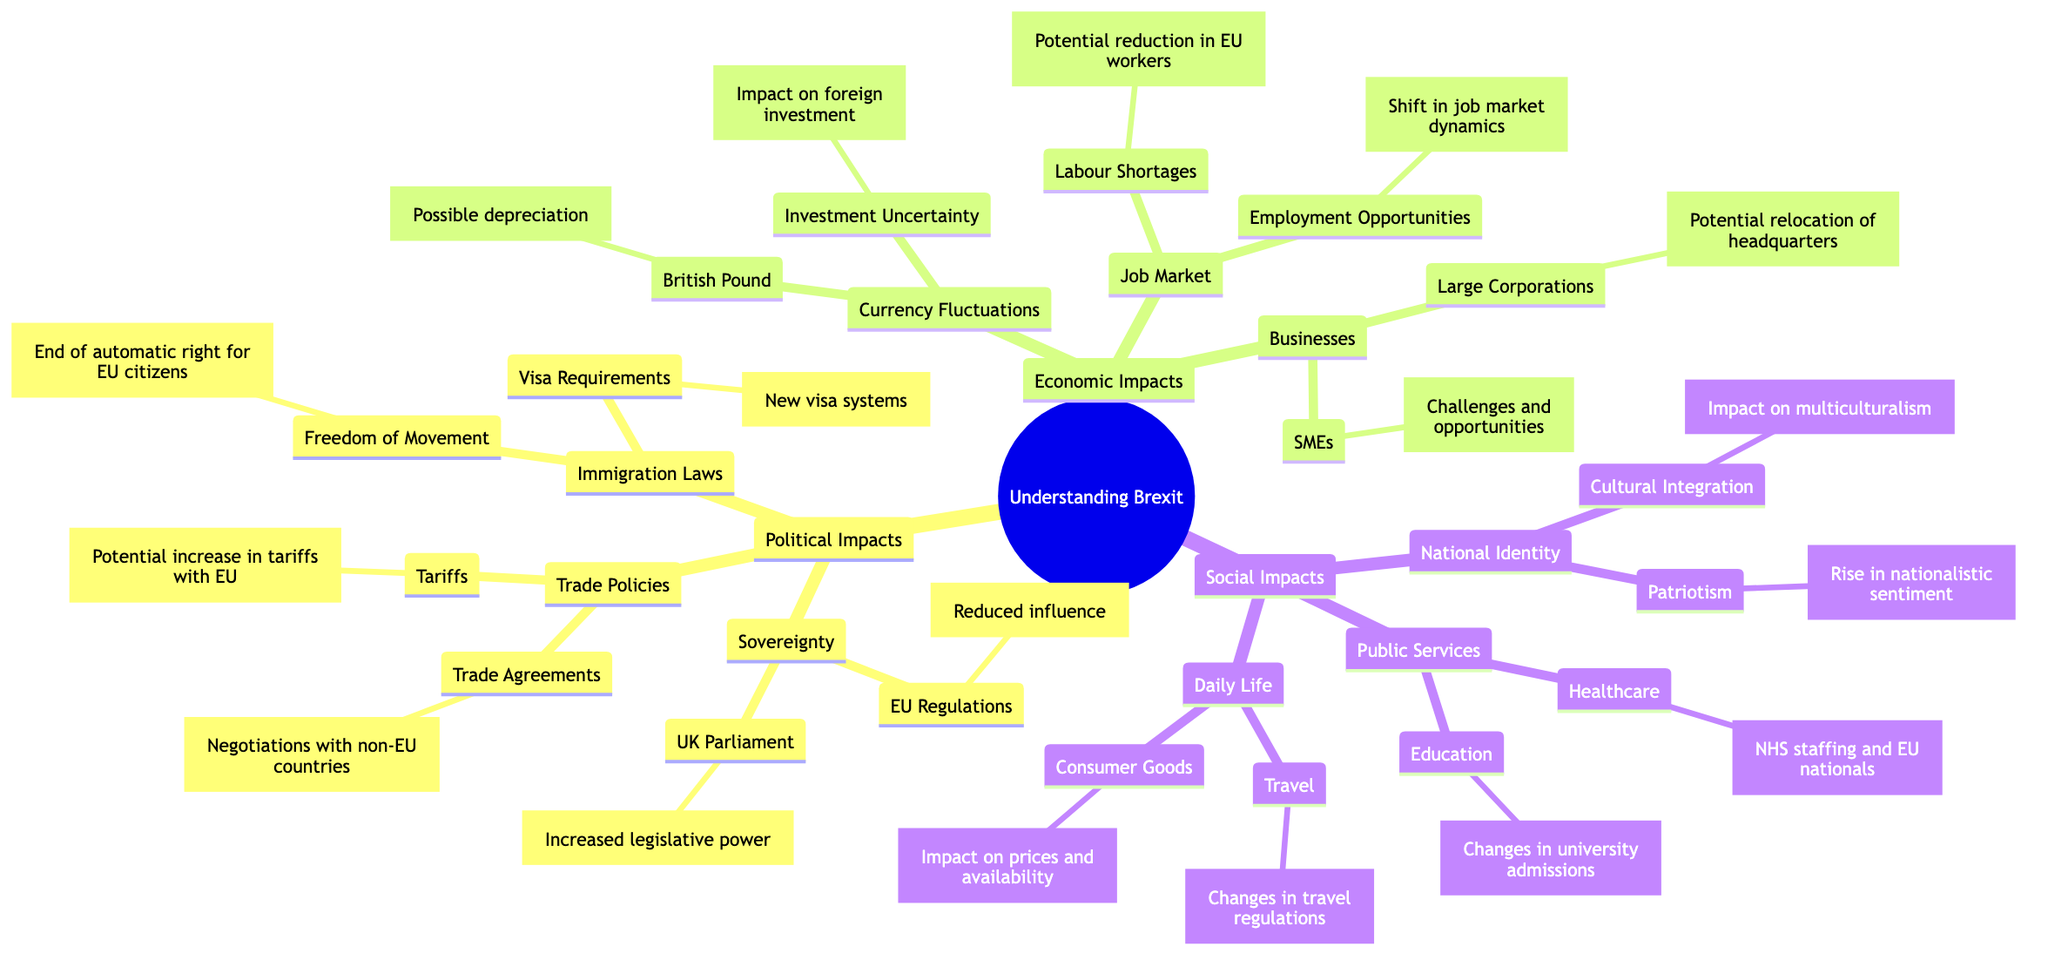What are the two main aspects of Political Impacts in the diagram? The diagram shows Political Impacts divided into three sections: Sovereignty, Trade Policies, and Immigration Laws. The question specifies to cite two aspects, so we can select any two from these three sections.
Answer: Sovereignty, Trade Policies How many aspects of Economic Impacts are detailed in the diagram? The Economic Impacts section has three sub-sections: Currency Fluctuations, Job Market, and Businesses, thus totaling three aspects.
Answer: 3 What does 'Freedom of Movement' refer to in the Immigration Laws section? In the diagram, 'Freedom of Movement' signifies the end of the automatic right for EU citizens to live and work in the UK. Therefore, it answers what this term conveys.
Answer: End of automatic right for EU citizens What might happen to the British Pound according to the Currency Fluctuations section? The Currency Fluctuations section specifies that the British Pound may face possible depreciation, indicating a potential decrease in its value.
Answer: Possible depreciation How does the rise in nationalistic sentiment affect Cultural Integration as seen in the diagram? The diagram links National Identity with Patriotism, which indicates a rise in nationalistic sentiment, and connects this concept to Cultural Integration that can have an impact on multiculturalism. Therefore, to answer this, we reason that increased nationalism may hinder cultural integration efforts.
Answer: Impact on multiculturalism What is one challenge that SMEs might face post-Brexit? The diagram states that SMEs face "Challenges and opportunities post-Brexit," highlighting the uncertainty and complexities they encounter during the transition period.
Answer: Challenges and opportunities How many total nodes are present under the Social Impacts section? The Social Impacts section contains three main areas: National Identity, Public Services, and Daily Life. Each of these areas includes multiple sub-nodes. Counting these, we find a total of seven nodes: National Identity (2), Public Services (2), and Daily Life (2). Thus, we simply add them up to determine the total count.
Answer: 7 What are the implications of 'Tariffs' as linked in the Trade Policies section? The diagram states that under Trade Policies, Tariffs may lead to a "Potential increase in tariffs with EU," indicating a direct result of Brexit-related changes to trade agreements.
Answer: Potential increase in tariffs with EU 